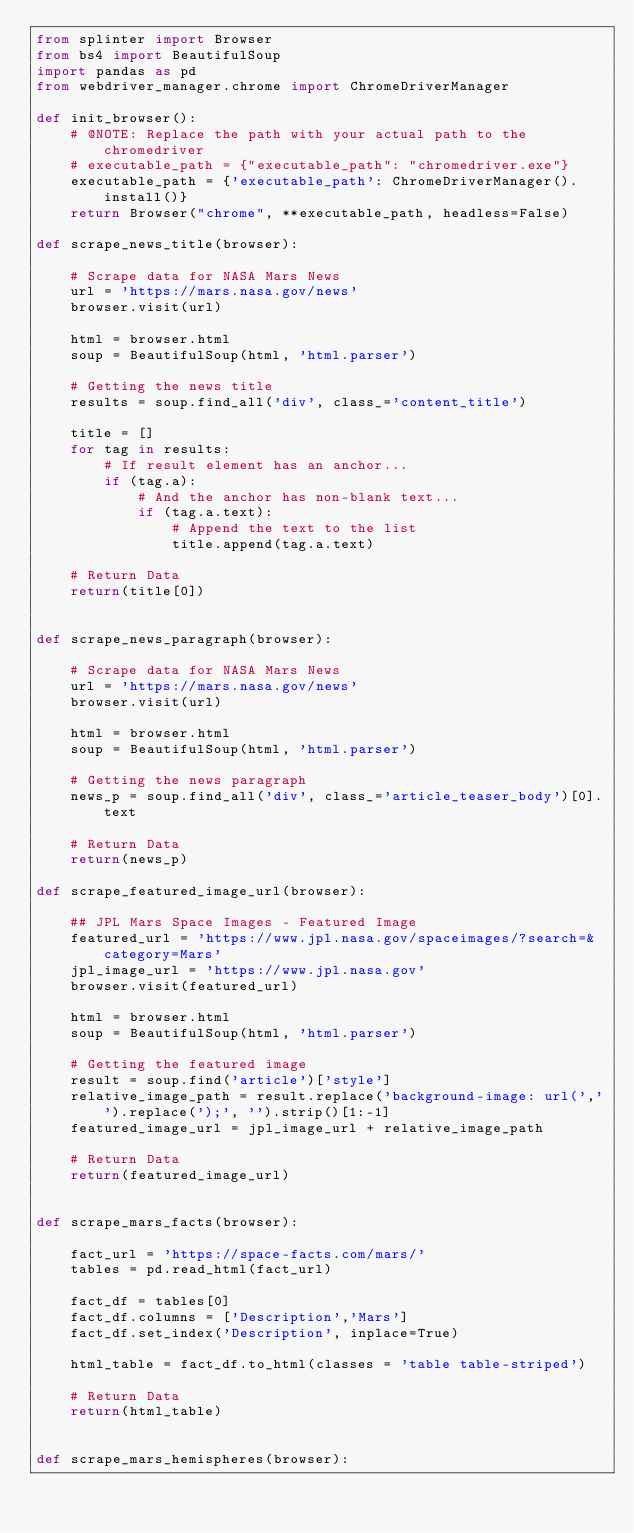Convert code to text. <code><loc_0><loc_0><loc_500><loc_500><_Python_>from splinter import Browser
from bs4 import BeautifulSoup
import pandas as pd
from webdriver_manager.chrome import ChromeDriverManager

def init_browser():
    # @NOTE: Replace the path with your actual path to the chromedriver
    # executable_path = {"executable_path": "chromedriver.exe"}
    executable_path = {'executable_path': ChromeDriverManager().install()} 
    return Browser("chrome", **executable_path, headless=False)

def scrape_news_title(browser):

    # Scrape data for NASA Mars News
    url = 'https://mars.nasa.gov/news'
    browser.visit(url)

    html = browser.html
    soup = BeautifulSoup(html, 'html.parser')
    
    # Getting the news title
    results = soup.find_all('div', class_='content_title')

    title = []
    for tag in results:
        # If result element has an anchor...
        if (tag.a):
            # And the anchor has non-blank text...
            if (tag.a.text):
                # Append the text to the list
                title.append(tag.a.text)

    # Return Data
    return(title[0])


def scrape_news_paragraph(browser):

    # Scrape data for NASA Mars News
    url = 'https://mars.nasa.gov/news'
    browser.visit(url)

    html = browser.html
    soup = BeautifulSoup(html, 'html.parser')

    # Getting the news paragraph
    news_p = soup.find_all('div', class_='article_teaser_body')[0].text

    # Return Data
    return(news_p)

def scrape_featured_image_url(browser):
    
    ## JPL Mars Space Images - Featured Image
    featured_url = 'https://www.jpl.nasa.gov/spaceimages/?search=&category=Mars'
    jpl_image_url = 'https://www.jpl.nasa.gov'
    browser.visit(featured_url)

    html = browser.html
    soup = BeautifulSoup(html, 'html.parser')

    # Getting the featured image
    result = soup.find('article')['style']
    relative_image_path = result.replace('background-image: url(','').replace(');', '').strip()[1:-1]
    featured_image_url = jpl_image_url + relative_image_path
    
    # Return Data
    return(featured_image_url)


def scrape_mars_facts(browser):
    
    fact_url = 'https://space-facts.com/mars/'
    tables = pd.read_html(fact_url)

    fact_df = tables[0]
    fact_df.columns = ['Description','Mars']
    fact_df.set_index('Description', inplace=True)

    html_table = fact_df.to_html(classes = 'table table-striped')

    # Return Data
    return(html_table)


def scrape_mars_hemispheres(browser):
</code> 